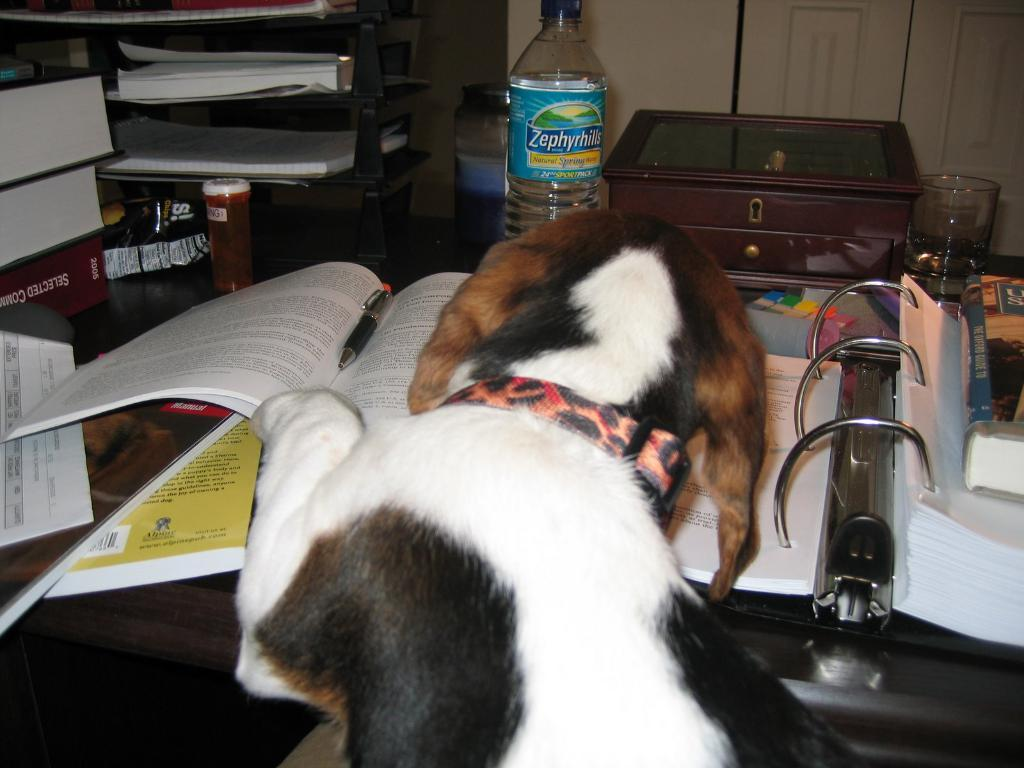What type of animal is in the picture? There is a dog in the picture. What is in front of the dog? There is a table in front of the dog. What items can be seen on the table? There are books, a water bottle, a box, a glass, and other objects on the table. What time of day is it in the image, and is the dog taking a bath in the tub? The time of day is not mentioned in the image, and there is no tub or indication of the dog taking a bath. 